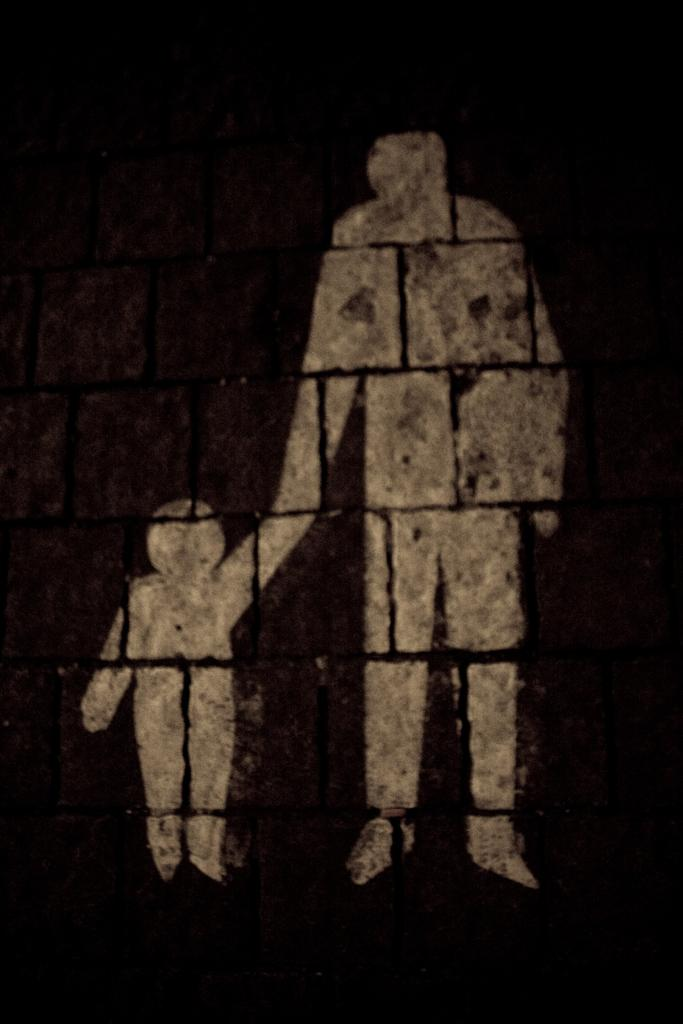What is on the wall in the image? There is a painting on the wall in the image. What color is the background of the image? The background of the image is black. Where can I find the shop mentioned in the painting? The painting does not mention a shop, and there is no shop present in the image. 